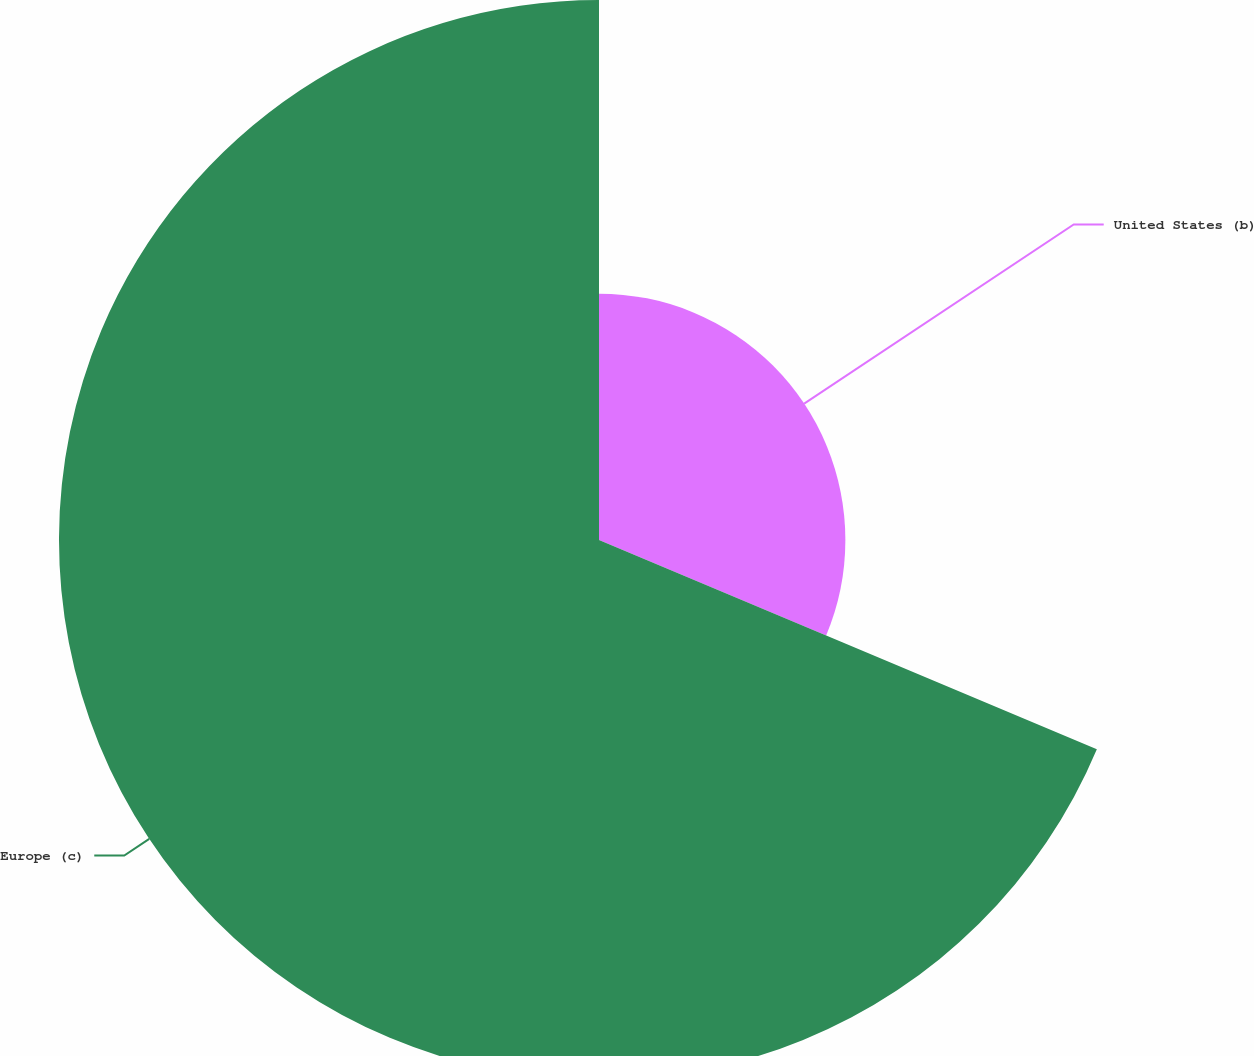Convert chart to OTSL. <chart><loc_0><loc_0><loc_500><loc_500><pie_chart><fcel>United States (b)<fcel>Europe (c)<nl><fcel>31.33%<fcel>68.67%<nl></chart> 